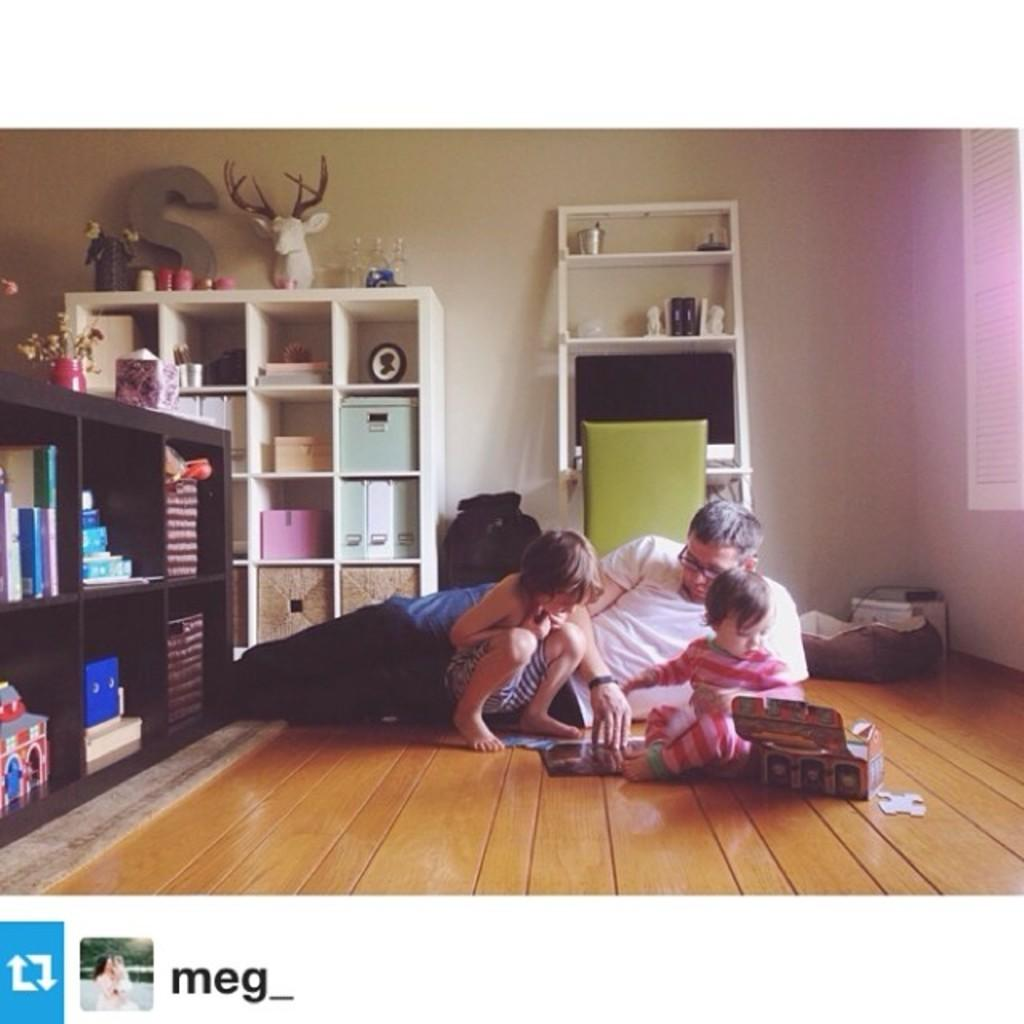<image>
Provide a brief description of the given image. A man and two children are reading a book on the floor and says its by meg. 